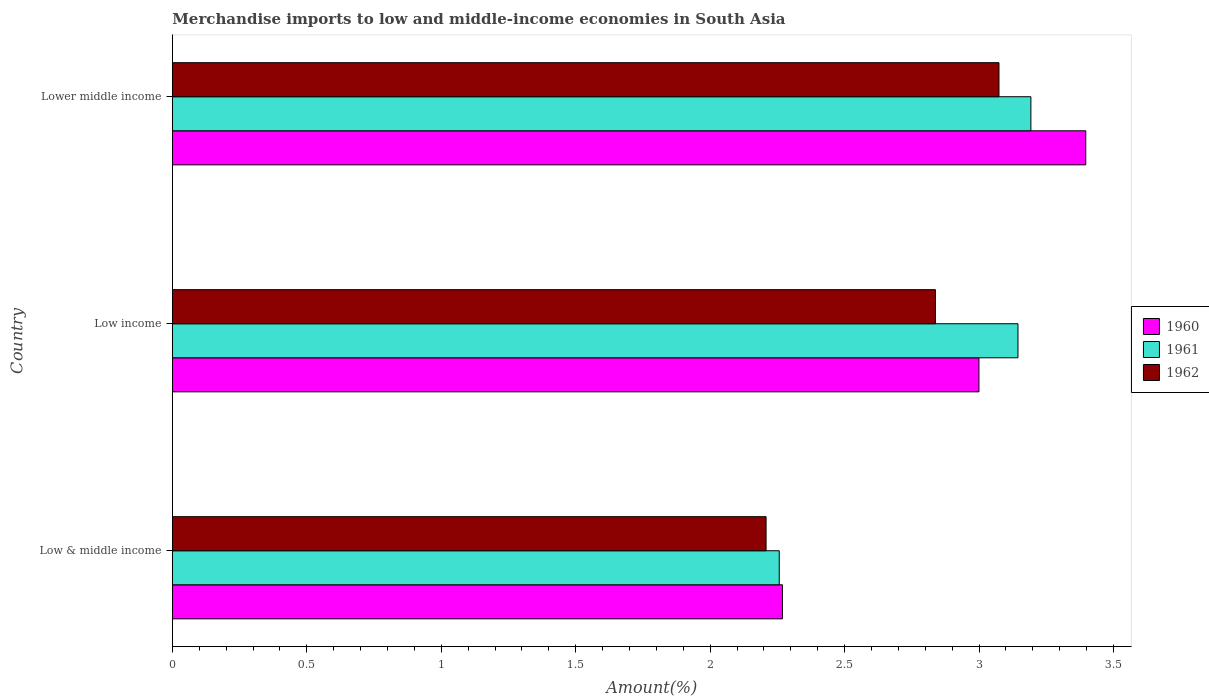How many groups of bars are there?
Make the answer very short. 3. Are the number of bars per tick equal to the number of legend labels?
Offer a very short reply. Yes. Are the number of bars on each tick of the Y-axis equal?
Your answer should be very brief. Yes. How many bars are there on the 2nd tick from the top?
Your answer should be very brief. 3. In how many cases, is the number of bars for a given country not equal to the number of legend labels?
Keep it short and to the point. 0. What is the percentage of amount earned from merchandise imports in 1960 in Low & middle income?
Provide a short and direct response. 2.27. Across all countries, what is the maximum percentage of amount earned from merchandise imports in 1961?
Provide a succinct answer. 3.19. Across all countries, what is the minimum percentage of amount earned from merchandise imports in 1960?
Make the answer very short. 2.27. In which country was the percentage of amount earned from merchandise imports in 1960 maximum?
Your answer should be very brief. Lower middle income. What is the total percentage of amount earned from merchandise imports in 1960 in the graph?
Your response must be concise. 8.66. What is the difference between the percentage of amount earned from merchandise imports in 1960 in Low income and that in Lower middle income?
Your answer should be very brief. -0.4. What is the difference between the percentage of amount earned from merchandise imports in 1961 in Lower middle income and the percentage of amount earned from merchandise imports in 1960 in Low income?
Offer a terse response. 0.19. What is the average percentage of amount earned from merchandise imports in 1960 per country?
Make the answer very short. 2.89. What is the difference between the percentage of amount earned from merchandise imports in 1961 and percentage of amount earned from merchandise imports in 1960 in Low & middle income?
Give a very brief answer. -0.01. What is the ratio of the percentage of amount earned from merchandise imports in 1962 in Low & middle income to that in Lower middle income?
Provide a succinct answer. 0.72. What is the difference between the highest and the second highest percentage of amount earned from merchandise imports in 1962?
Keep it short and to the point. 0.24. What is the difference between the highest and the lowest percentage of amount earned from merchandise imports in 1961?
Your response must be concise. 0.94. In how many countries, is the percentage of amount earned from merchandise imports in 1960 greater than the average percentage of amount earned from merchandise imports in 1960 taken over all countries?
Your response must be concise. 2. Is the sum of the percentage of amount earned from merchandise imports in 1962 in Low & middle income and Lower middle income greater than the maximum percentage of amount earned from merchandise imports in 1961 across all countries?
Your answer should be very brief. Yes. What does the 2nd bar from the bottom in Lower middle income represents?
Your answer should be compact. 1961. Is it the case that in every country, the sum of the percentage of amount earned from merchandise imports in 1961 and percentage of amount earned from merchandise imports in 1962 is greater than the percentage of amount earned from merchandise imports in 1960?
Give a very brief answer. Yes. How many bars are there?
Give a very brief answer. 9. Are all the bars in the graph horizontal?
Ensure brevity in your answer.  Yes. Does the graph contain any zero values?
Your response must be concise. No. What is the title of the graph?
Provide a short and direct response. Merchandise imports to low and middle-income economies in South Asia. What is the label or title of the X-axis?
Give a very brief answer. Amount(%). What is the Amount(%) in 1960 in Low & middle income?
Keep it short and to the point. 2.27. What is the Amount(%) in 1961 in Low & middle income?
Keep it short and to the point. 2.26. What is the Amount(%) of 1962 in Low & middle income?
Make the answer very short. 2.21. What is the Amount(%) of 1960 in Low income?
Make the answer very short. 3. What is the Amount(%) in 1961 in Low income?
Provide a short and direct response. 3.14. What is the Amount(%) in 1962 in Low income?
Ensure brevity in your answer.  2.84. What is the Amount(%) in 1960 in Lower middle income?
Provide a short and direct response. 3.4. What is the Amount(%) in 1961 in Lower middle income?
Give a very brief answer. 3.19. What is the Amount(%) in 1962 in Lower middle income?
Provide a short and direct response. 3.07. Across all countries, what is the maximum Amount(%) of 1960?
Ensure brevity in your answer.  3.4. Across all countries, what is the maximum Amount(%) in 1961?
Provide a short and direct response. 3.19. Across all countries, what is the maximum Amount(%) of 1962?
Ensure brevity in your answer.  3.07. Across all countries, what is the minimum Amount(%) of 1960?
Make the answer very short. 2.27. Across all countries, what is the minimum Amount(%) of 1961?
Give a very brief answer. 2.26. Across all countries, what is the minimum Amount(%) in 1962?
Offer a terse response. 2.21. What is the total Amount(%) of 1960 in the graph?
Make the answer very short. 8.66. What is the total Amount(%) of 1961 in the graph?
Ensure brevity in your answer.  8.59. What is the total Amount(%) of 1962 in the graph?
Ensure brevity in your answer.  8.12. What is the difference between the Amount(%) in 1960 in Low & middle income and that in Low income?
Give a very brief answer. -0.73. What is the difference between the Amount(%) of 1961 in Low & middle income and that in Low income?
Ensure brevity in your answer.  -0.89. What is the difference between the Amount(%) of 1962 in Low & middle income and that in Low income?
Offer a terse response. -0.63. What is the difference between the Amount(%) in 1960 in Low & middle income and that in Lower middle income?
Provide a short and direct response. -1.13. What is the difference between the Amount(%) in 1961 in Low & middle income and that in Lower middle income?
Your answer should be very brief. -0.94. What is the difference between the Amount(%) in 1962 in Low & middle income and that in Lower middle income?
Your answer should be compact. -0.87. What is the difference between the Amount(%) of 1960 in Low income and that in Lower middle income?
Ensure brevity in your answer.  -0.4. What is the difference between the Amount(%) of 1961 in Low income and that in Lower middle income?
Your answer should be very brief. -0.05. What is the difference between the Amount(%) in 1962 in Low income and that in Lower middle income?
Your answer should be very brief. -0.24. What is the difference between the Amount(%) in 1960 in Low & middle income and the Amount(%) in 1961 in Low income?
Give a very brief answer. -0.88. What is the difference between the Amount(%) of 1960 in Low & middle income and the Amount(%) of 1962 in Low income?
Make the answer very short. -0.57. What is the difference between the Amount(%) of 1961 in Low & middle income and the Amount(%) of 1962 in Low income?
Provide a short and direct response. -0.58. What is the difference between the Amount(%) of 1960 in Low & middle income and the Amount(%) of 1961 in Lower middle income?
Provide a succinct answer. -0.92. What is the difference between the Amount(%) of 1960 in Low & middle income and the Amount(%) of 1962 in Lower middle income?
Provide a succinct answer. -0.81. What is the difference between the Amount(%) in 1961 in Low & middle income and the Amount(%) in 1962 in Lower middle income?
Provide a short and direct response. -0.82. What is the difference between the Amount(%) of 1960 in Low income and the Amount(%) of 1961 in Lower middle income?
Your answer should be compact. -0.19. What is the difference between the Amount(%) in 1960 in Low income and the Amount(%) in 1962 in Lower middle income?
Offer a very short reply. -0.07. What is the difference between the Amount(%) in 1961 in Low income and the Amount(%) in 1962 in Lower middle income?
Provide a succinct answer. 0.07. What is the average Amount(%) of 1960 per country?
Your answer should be very brief. 2.89. What is the average Amount(%) of 1961 per country?
Make the answer very short. 2.86. What is the average Amount(%) of 1962 per country?
Provide a succinct answer. 2.71. What is the difference between the Amount(%) in 1960 and Amount(%) in 1961 in Low & middle income?
Provide a short and direct response. 0.01. What is the difference between the Amount(%) of 1960 and Amount(%) of 1962 in Low & middle income?
Offer a terse response. 0.06. What is the difference between the Amount(%) in 1961 and Amount(%) in 1962 in Low & middle income?
Offer a terse response. 0.05. What is the difference between the Amount(%) of 1960 and Amount(%) of 1961 in Low income?
Your answer should be compact. -0.15. What is the difference between the Amount(%) in 1960 and Amount(%) in 1962 in Low income?
Make the answer very short. 0.16. What is the difference between the Amount(%) of 1961 and Amount(%) of 1962 in Low income?
Ensure brevity in your answer.  0.31. What is the difference between the Amount(%) in 1960 and Amount(%) in 1961 in Lower middle income?
Keep it short and to the point. 0.2. What is the difference between the Amount(%) of 1960 and Amount(%) of 1962 in Lower middle income?
Your answer should be very brief. 0.32. What is the difference between the Amount(%) in 1961 and Amount(%) in 1962 in Lower middle income?
Give a very brief answer. 0.12. What is the ratio of the Amount(%) of 1960 in Low & middle income to that in Low income?
Give a very brief answer. 0.76. What is the ratio of the Amount(%) of 1961 in Low & middle income to that in Low income?
Ensure brevity in your answer.  0.72. What is the ratio of the Amount(%) in 1962 in Low & middle income to that in Low income?
Provide a succinct answer. 0.78. What is the ratio of the Amount(%) in 1960 in Low & middle income to that in Lower middle income?
Ensure brevity in your answer.  0.67. What is the ratio of the Amount(%) of 1961 in Low & middle income to that in Lower middle income?
Offer a terse response. 0.71. What is the ratio of the Amount(%) in 1962 in Low & middle income to that in Lower middle income?
Offer a very short reply. 0.72. What is the ratio of the Amount(%) in 1960 in Low income to that in Lower middle income?
Provide a short and direct response. 0.88. What is the ratio of the Amount(%) in 1961 in Low income to that in Lower middle income?
Ensure brevity in your answer.  0.98. What is the ratio of the Amount(%) of 1962 in Low income to that in Lower middle income?
Make the answer very short. 0.92. What is the difference between the highest and the second highest Amount(%) in 1960?
Your response must be concise. 0.4. What is the difference between the highest and the second highest Amount(%) of 1961?
Give a very brief answer. 0.05. What is the difference between the highest and the second highest Amount(%) of 1962?
Keep it short and to the point. 0.24. What is the difference between the highest and the lowest Amount(%) of 1960?
Your answer should be compact. 1.13. What is the difference between the highest and the lowest Amount(%) of 1961?
Provide a short and direct response. 0.94. What is the difference between the highest and the lowest Amount(%) in 1962?
Provide a succinct answer. 0.87. 